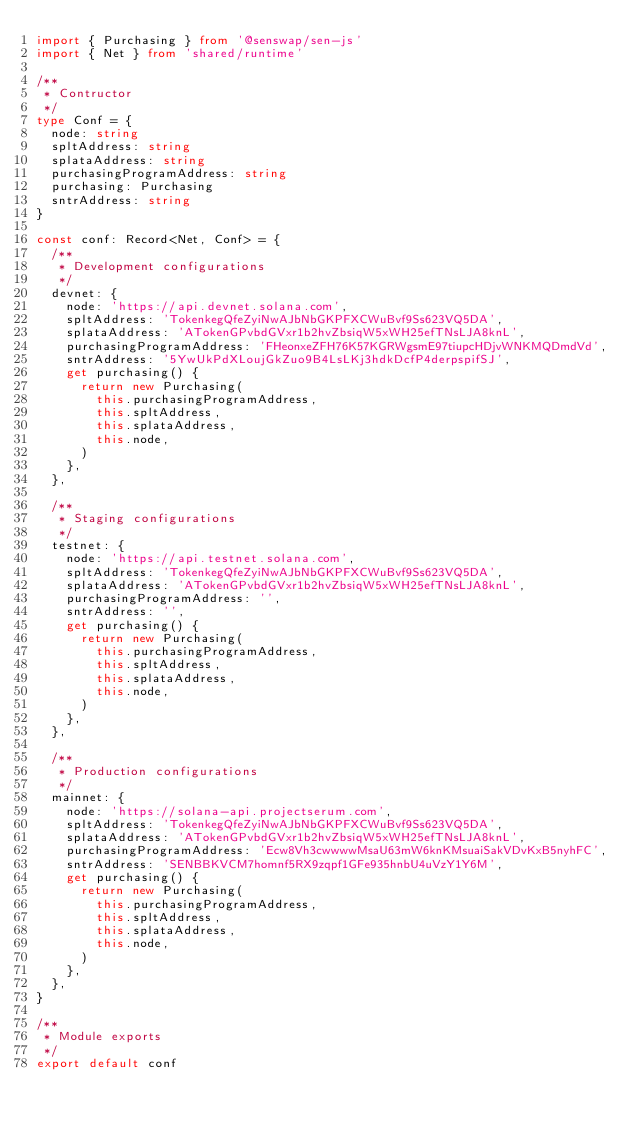<code> <loc_0><loc_0><loc_500><loc_500><_TypeScript_>import { Purchasing } from '@senswap/sen-js'
import { Net } from 'shared/runtime'

/**
 * Contructor
 */
type Conf = {
  node: string
  spltAddress: string
  splataAddress: string
  purchasingProgramAddress: string
  purchasing: Purchasing
  sntrAddress: string
}

const conf: Record<Net, Conf> = {
  /**
   * Development configurations
   */
  devnet: {
    node: 'https://api.devnet.solana.com',
    spltAddress: 'TokenkegQfeZyiNwAJbNbGKPFXCWuBvf9Ss623VQ5DA',
    splataAddress: 'ATokenGPvbdGVxr1b2hvZbsiqW5xWH25efTNsLJA8knL',
    purchasingProgramAddress: 'FHeonxeZFH76K57KGRWgsmE97tiupcHDjvWNKMQDmdVd',
    sntrAddress: '5YwUkPdXLoujGkZuo9B4LsLKj3hdkDcfP4derpspifSJ',
    get purchasing() {
      return new Purchasing(
        this.purchasingProgramAddress,
        this.spltAddress,
        this.splataAddress,
        this.node,
      )
    },
  },

  /**
   * Staging configurations
   */
  testnet: {
    node: 'https://api.testnet.solana.com',
    spltAddress: 'TokenkegQfeZyiNwAJbNbGKPFXCWuBvf9Ss623VQ5DA',
    splataAddress: 'ATokenGPvbdGVxr1b2hvZbsiqW5xWH25efTNsLJA8knL',
    purchasingProgramAddress: '',
    sntrAddress: '',
    get purchasing() {
      return new Purchasing(
        this.purchasingProgramAddress,
        this.spltAddress,
        this.splataAddress,
        this.node,
      )
    },
  },

  /**
   * Production configurations
   */
  mainnet: {
    node: 'https://solana-api.projectserum.com',
    spltAddress: 'TokenkegQfeZyiNwAJbNbGKPFXCWuBvf9Ss623VQ5DA',
    splataAddress: 'ATokenGPvbdGVxr1b2hvZbsiqW5xWH25efTNsLJA8knL',
    purchasingProgramAddress: 'Ecw8Vh3cwwwwMsaU63mW6knKMsuaiSakVDvKxB5nyhFC',
    sntrAddress: 'SENBBKVCM7homnf5RX9zqpf1GFe935hnbU4uVzY1Y6M',
    get purchasing() {
      return new Purchasing(
        this.purchasingProgramAddress,
        this.spltAddress,
        this.splataAddress,
        this.node,
      )
    },
  },
}

/**
 * Module exports
 */
export default conf
</code> 